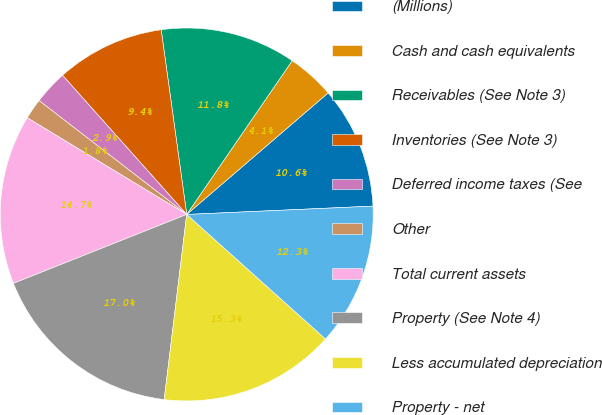Convert chart. <chart><loc_0><loc_0><loc_500><loc_500><pie_chart><fcel>(Millions)<fcel>Cash and cash equivalents<fcel>Receivables (See Note 3)<fcel>Inventories (See Note 3)<fcel>Deferred income taxes (See<fcel>Other<fcel>Total current assets<fcel>Property (See Note 4)<fcel>Less accumulated depreciation<fcel>Property - net<nl><fcel>10.59%<fcel>4.13%<fcel>11.76%<fcel>9.41%<fcel>2.95%<fcel>1.78%<fcel>14.7%<fcel>17.05%<fcel>15.29%<fcel>12.35%<nl></chart> 